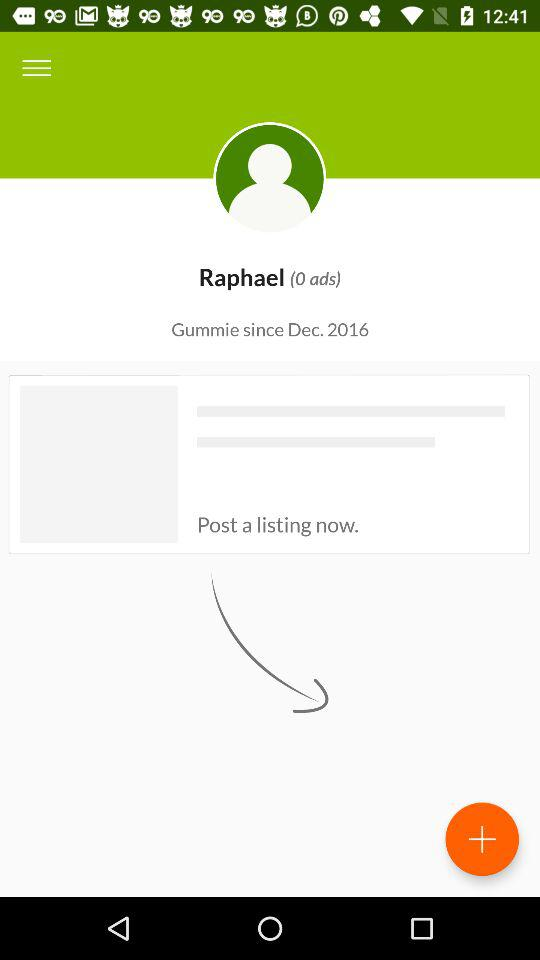What is the user name? The user name is Raphael. 